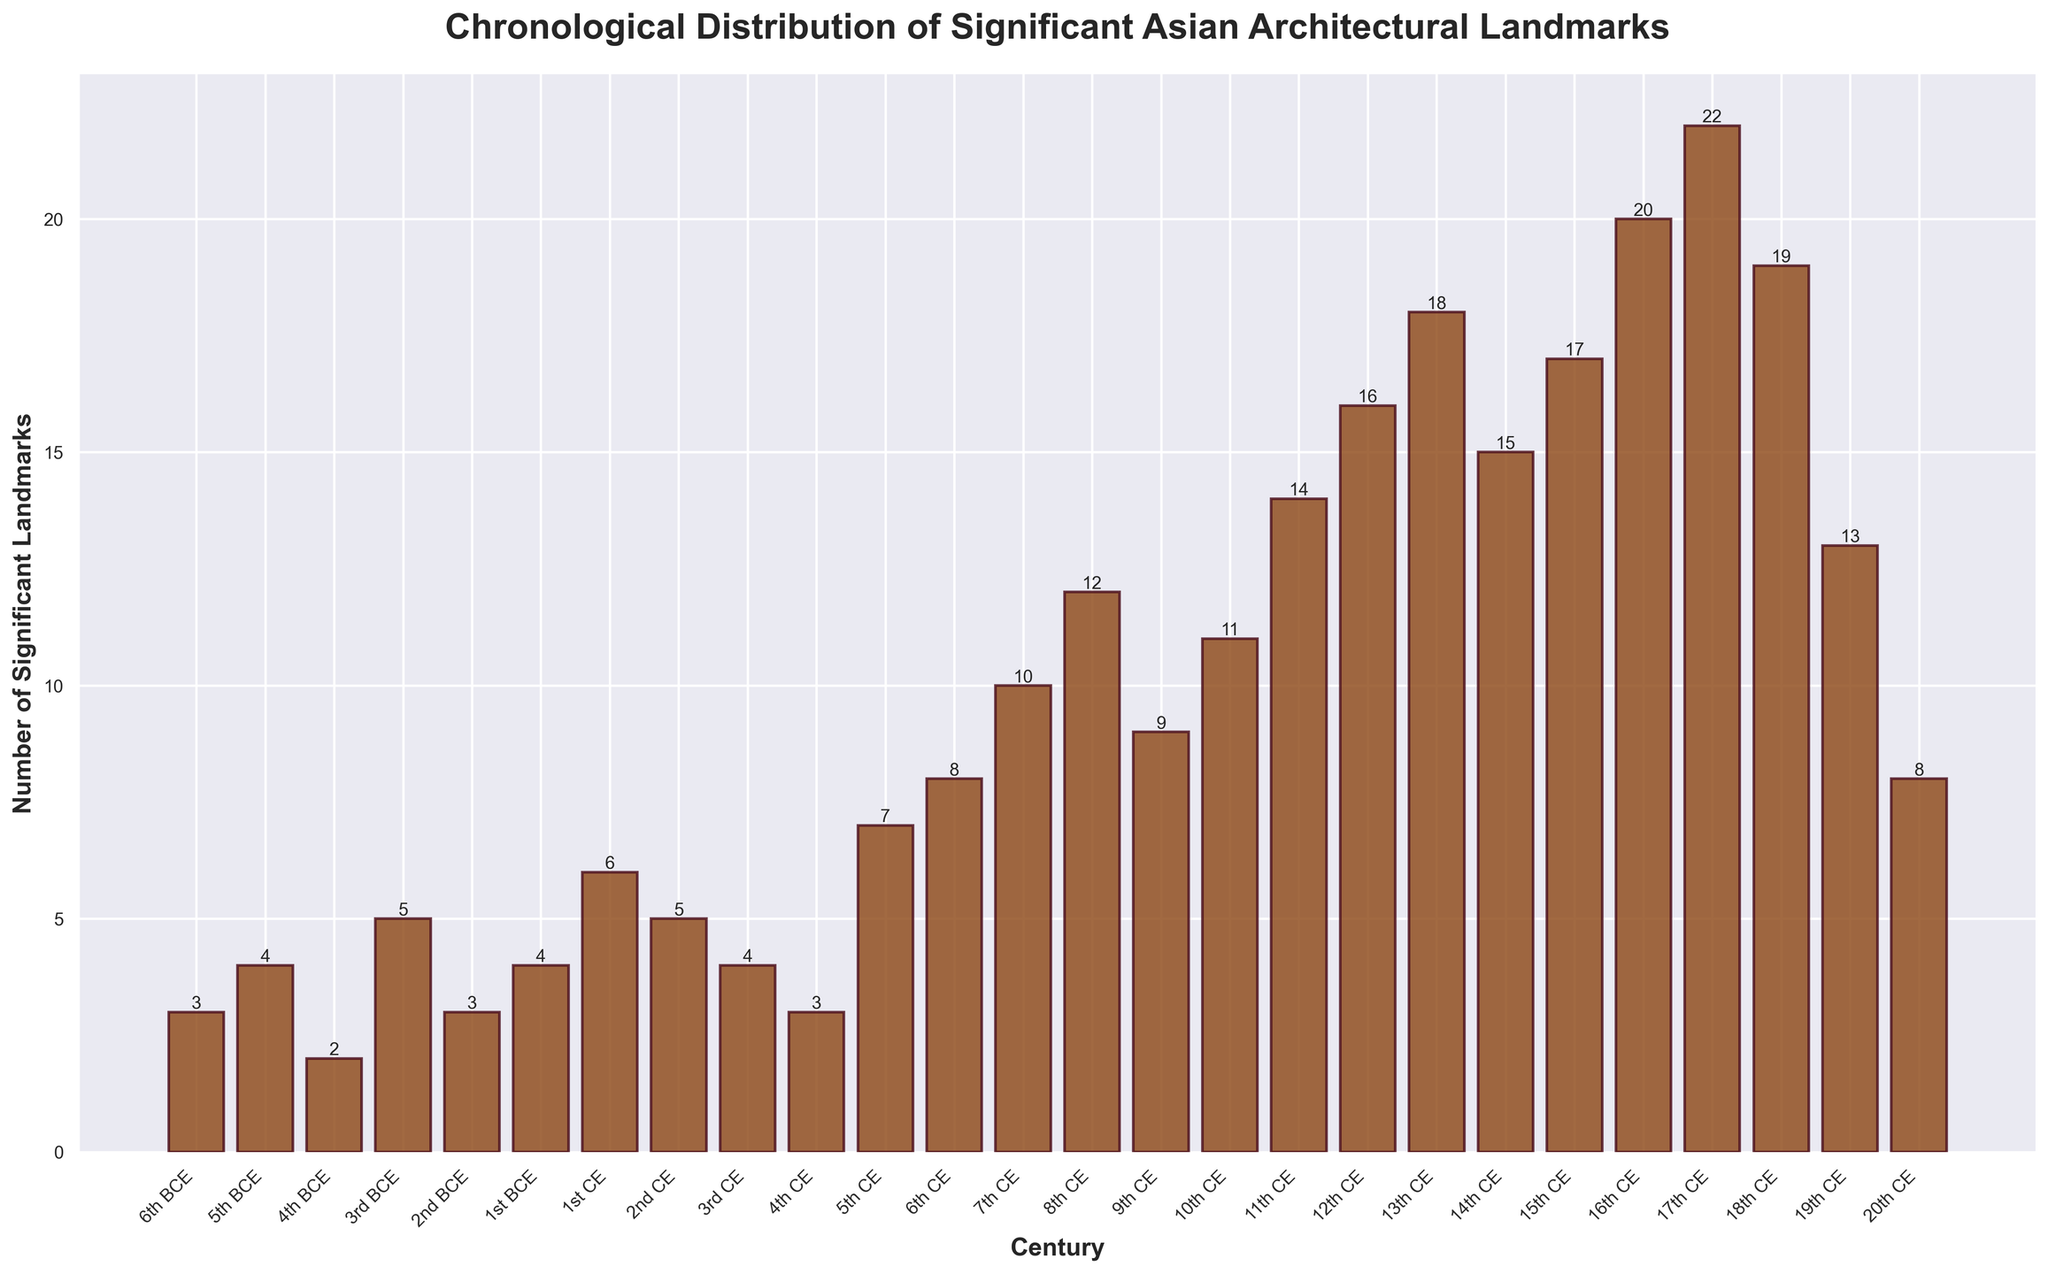Which century has the highest number of significant landmarks? The bar for the 17th century reaches the highest point on the y-axis and is labeled with the highest value of 22. This indicates that the 17th century has the most significant landmarks.
Answer: 17th century Which two centuries have the same number of significant landmarks? From the figure, the bars for the 1st CE and 2nd CE centuries both reach the height corresponding to the value 5, indicating they have the same number of significant landmarks.
Answer: 1st CE and 2nd CE How do the number of significant landmarks in the 10th CE compare to those in the 9th CE? The bar for the 10th CE reaches the value 11, while the bar for the 9th CE reaches the value 9. Thus, the 10th CE has more significant landmarks than the 9th CE.
Answer: The 10th CE has 2 more significant landmarks than the 9th CE What is the average number of significant landmarks per century from the 16th CE to the 19th CE? Sum the values from the 16th CE (20), 17th CE (22), 18th CE (19), and 19th CE (13) which equals 74. There are 4 centuries considered, thus the average is 74/4 = 18.5.
Answer: 18.5 Which century has the lowest number of significant landmarks and how many are there? The bar for the 4th BCE century reaches the lowest point on the y-axis with a value of 2, indicating it has the fewest significant landmarks.
Answer: 4th BCE with 2 landmarks What is the combined number of significant landmarks in the 12th CE and 13th CE centuries? The bar for the 12th CE reaches the value 16 and the bar for the 13th CE reaches the value 18. Adding these gives 16 + 18 = 34.
Answer: 34 How did the number of significant landmarks change from the 11th CE to the 14th CE? The values for the 11th CE, 12th CE, 13th CE, and 14th CE are 14, 16, 18, and 15 respectively. The number increases from 11th to 13th CE and then decreases in the 14th CE.
Answer: Increase and then decrease Is there a century where the number of significant landmarks is exactly 8? From the visualized data, the bar for the 6th CE century reaches the value of 8, indicating it has exactly 8 significant landmarks.
Answer: 6th CE What is the most distinguishing feature of the bars representing the 6th BCE and 20th CE? Both bars reach a height corresponding to the value 3, visually confirming they represent the same number of significant landmarks.
Answer: Both have 3 landmarks How many centuries have a number of significant landmarks greater than 10? The bars for the 10th CE (11), 11th CE (14), 12th CE (16), 13th CE (18), 14th CE (15), 15th CE (17), 16th CE (20), 17th CE (22), and 18th CE (19) all have counts greater than 10, totaling 9 centuries.
Answer: 9 